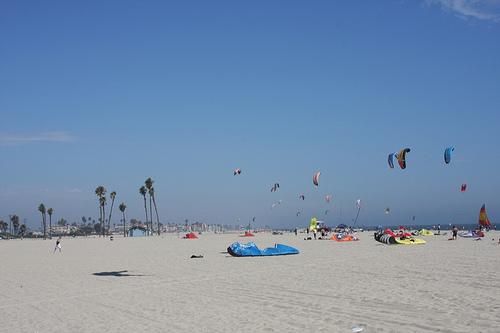IS there snow?
Give a very brief answer. No. What is laying on the sand?
Give a very brief answer. Towels. What kind of trees are in the background?
Keep it brief. Palm. Is this a vacation setting?
Write a very short answer. Yes. What is covering the ground?
Give a very brief answer. Sand. What color is the sand?
Keep it brief. White. Is it cold?
Short answer required. No. What color is the chair in the sand?
Write a very short answer. Blue. In what season is the person flying the kite?
Concise answer only. Summer. Is the sun shining?
Answer briefly. Yes. What kind of season is it?
Short answer required. Summer. Is the wind blowing right to left?
Be succinct. Yes. Is this winter?
Write a very short answer. No. Is it summer or winter?
Answer briefly. Summer. What season is it?
Write a very short answer. Summer. How many kites are in the air?
Answer briefly. 15. Is it winter?
Concise answer only. No. Is it sunny outside?
Concise answer only. Yes. How many kites are the people flying on the beach?
Short answer required. 20. How many umbrellas are there?
Be succinct. 0. Is it going to rain?
Give a very brief answer. No. Is it cold outside?
Concise answer only. No. Does this scene feature snow or a beach?
Give a very brief answer. Beach. 